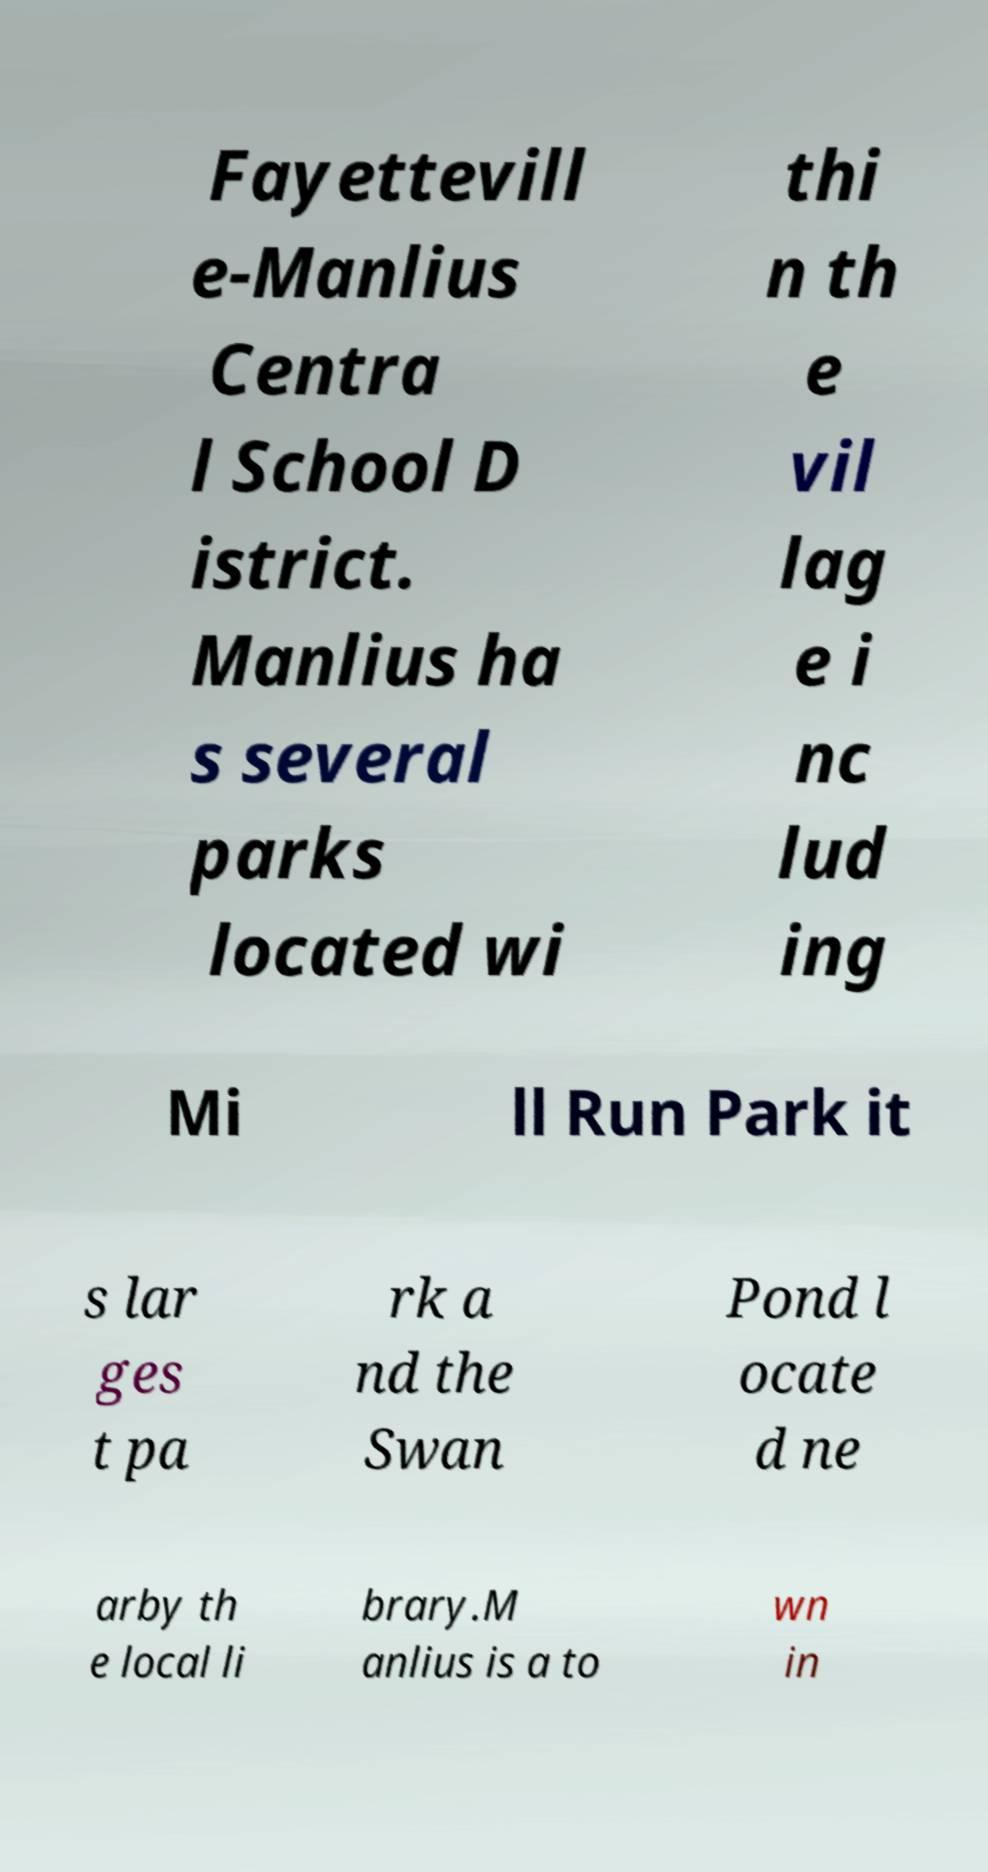What messages or text are displayed in this image? I need them in a readable, typed format. Fayettevill e-Manlius Centra l School D istrict. Manlius ha s several parks located wi thi n th e vil lag e i nc lud ing Mi ll Run Park it s lar ges t pa rk a nd the Swan Pond l ocate d ne arby th e local li brary.M anlius is a to wn in 